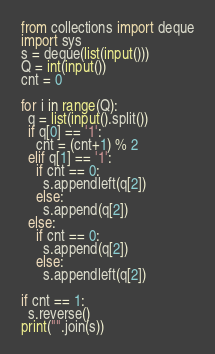<code> <loc_0><loc_0><loc_500><loc_500><_Python_>from collections import deque
import sys
s = deque(list(input()))
Q = int(input())
cnt = 0

for i in range(Q):
  q = list(input().split())
  if q[0] == '1':
    cnt = (cnt+1) % 2
  elif q[1] == '1':
    if cnt == 0:
      s.appendleft(q[2])
    else:
      s.append(q[2])
  else:
    if cnt == 0:
      s.append(q[2])
    else:
      s.appendleft(q[2])

if cnt == 1:
  s.reverse()
print("".join(s))</code> 